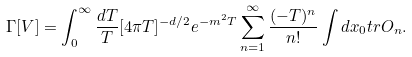<formula> <loc_0><loc_0><loc_500><loc_500>\Gamma [ V ] = \int _ { 0 } ^ { \infty } \frac { d T } { T } [ 4 \pi T ] ^ { - d / 2 } e ^ { - m ^ { 2 } T } \sum _ { n = 1 } ^ { \infty } \frac { ( - T ) ^ { n } } { n ! } \int d x _ { 0 } t r O _ { n } .</formula> 